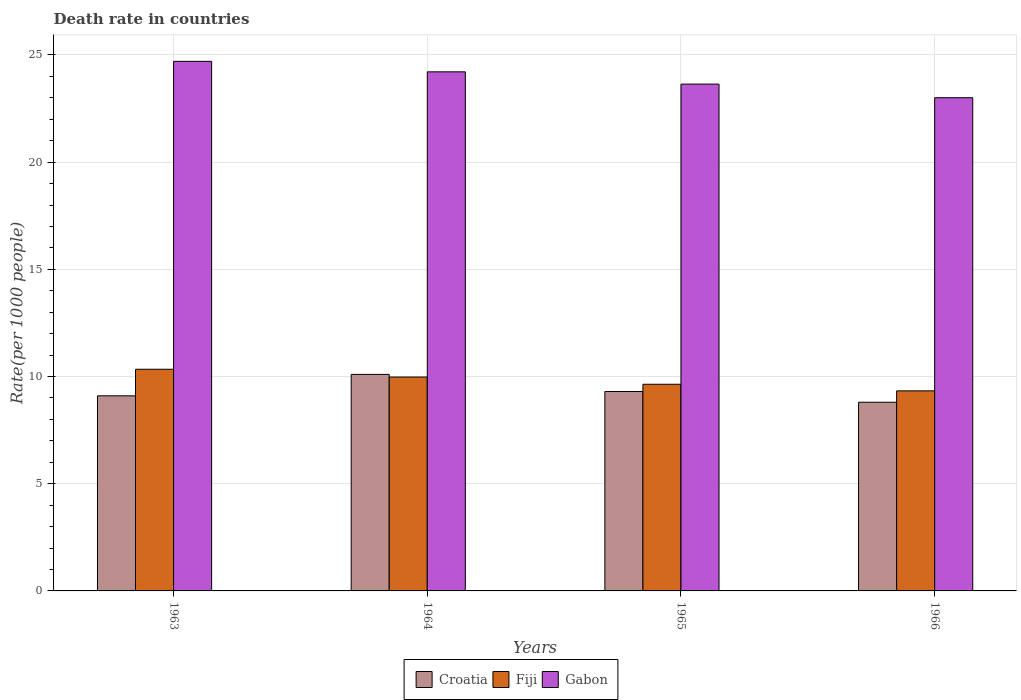How many different coloured bars are there?
Ensure brevity in your answer.  3. How many groups of bars are there?
Ensure brevity in your answer.  4. Are the number of bars per tick equal to the number of legend labels?
Your answer should be very brief. Yes. Are the number of bars on each tick of the X-axis equal?
Provide a short and direct response. Yes. What is the label of the 3rd group of bars from the left?
Keep it short and to the point. 1965. Across all years, what is the maximum death rate in Croatia?
Your response must be concise. 10.1. Across all years, what is the minimum death rate in Gabon?
Your response must be concise. 23. In which year was the death rate in Croatia minimum?
Your answer should be very brief. 1966. What is the total death rate in Fiji in the graph?
Your answer should be compact. 39.28. What is the difference between the death rate in Fiji in 1964 and that in 1966?
Your answer should be very brief. 0.65. What is the difference between the death rate in Fiji in 1966 and the death rate in Croatia in 1963?
Your answer should be compact. 0.23. What is the average death rate in Gabon per year?
Make the answer very short. 23.89. In the year 1964, what is the difference between the death rate in Croatia and death rate in Gabon?
Provide a succinct answer. -14.11. In how many years, is the death rate in Gabon greater than 9?
Your answer should be compact. 4. What is the ratio of the death rate in Fiji in 1964 to that in 1966?
Provide a short and direct response. 1.07. Is the death rate in Fiji in 1964 less than that in 1965?
Provide a succinct answer. No. What is the difference between the highest and the second highest death rate in Croatia?
Provide a short and direct response. 0.8. What is the difference between the highest and the lowest death rate in Fiji?
Your answer should be compact. 1.01. Is the sum of the death rate in Fiji in 1963 and 1964 greater than the maximum death rate in Croatia across all years?
Your response must be concise. Yes. What does the 1st bar from the left in 1966 represents?
Offer a terse response. Croatia. What does the 3rd bar from the right in 1964 represents?
Give a very brief answer. Croatia. Is it the case that in every year, the sum of the death rate in Gabon and death rate in Fiji is greater than the death rate in Croatia?
Provide a short and direct response. Yes. How many bars are there?
Provide a short and direct response. 12. What is the difference between two consecutive major ticks on the Y-axis?
Your response must be concise. 5. Does the graph contain grids?
Provide a short and direct response. Yes. Where does the legend appear in the graph?
Your answer should be compact. Bottom center. What is the title of the graph?
Provide a succinct answer. Death rate in countries. What is the label or title of the Y-axis?
Offer a very short reply. Rate(per 1000 people). What is the Rate(per 1000 people) of Fiji in 1963?
Keep it short and to the point. 10.34. What is the Rate(per 1000 people) in Gabon in 1963?
Make the answer very short. 24.7. What is the Rate(per 1000 people) of Fiji in 1964?
Give a very brief answer. 9.98. What is the Rate(per 1000 people) of Gabon in 1964?
Your response must be concise. 24.21. What is the Rate(per 1000 people) of Croatia in 1965?
Give a very brief answer. 9.3. What is the Rate(per 1000 people) of Fiji in 1965?
Make the answer very short. 9.64. What is the Rate(per 1000 people) of Gabon in 1965?
Make the answer very short. 23.64. What is the Rate(per 1000 people) of Croatia in 1966?
Your answer should be compact. 8.8. What is the Rate(per 1000 people) of Fiji in 1966?
Make the answer very short. 9.33. What is the Rate(per 1000 people) in Gabon in 1966?
Your answer should be compact. 23. Across all years, what is the maximum Rate(per 1000 people) of Fiji?
Keep it short and to the point. 10.34. Across all years, what is the maximum Rate(per 1000 people) in Gabon?
Offer a very short reply. 24.7. Across all years, what is the minimum Rate(per 1000 people) in Croatia?
Offer a terse response. 8.8. Across all years, what is the minimum Rate(per 1000 people) of Fiji?
Your answer should be compact. 9.33. Across all years, what is the minimum Rate(per 1000 people) in Gabon?
Keep it short and to the point. 23. What is the total Rate(per 1000 people) in Croatia in the graph?
Provide a succinct answer. 37.3. What is the total Rate(per 1000 people) of Fiji in the graph?
Provide a short and direct response. 39.28. What is the total Rate(per 1000 people) in Gabon in the graph?
Make the answer very short. 95.55. What is the difference between the Rate(per 1000 people) of Croatia in 1963 and that in 1964?
Your response must be concise. -1. What is the difference between the Rate(per 1000 people) in Fiji in 1963 and that in 1964?
Give a very brief answer. 0.36. What is the difference between the Rate(per 1000 people) in Gabon in 1963 and that in 1964?
Offer a terse response. 0.49. What is the difference between the Rate(per 1000 people) of Croatia in 1963 and that in 1965?
Keep it short and to the point. -0.2. What is the difference between the Rate(per 1000 people) in Fiji in 1963 and that in 1965?
Provide a succinct answer. 0.7. What is the difference between the Rate(per 1000 people) of Gabon in 1963 and that in 1965?
Offer a terse response. 1.06. What is the difference between the Rate(per 1000 people) of Fiji in 1963 and that in 1966?
Offer a terse response. 1.01. What is the difference between the Rate(per 1000 people) of Gabon in 1963 and that in 1966?
Your response must be concise. 1.7. What is the difference between the Rate(per 1000 people) of Croatia in 1964 and that in 1965?
Make the answer very short. 0.8. What is the difference between the Rate(per 1000 people) in Fiji in 1964 and that in 1965?
Provide a succinct answer. 0.34. What is the difference between the Rate(per 1000 people) of Gabon in 1964 and that in 1965?
Offer a terse response. 0.57. What is the difference between the Rate(per 1000 people) of Croatia in 1964 and that in 1966?
Offer a terse response. 1.3. What is the difference between the Rate(per 1000 people) in Fiji in 1964 and that in 1966?
Your answer should be compact. 0.65. What is the difference between the Rate(per 1000 people) in Gabon in 1964 and that in 1966?
Offer a very short reply. 1.21. What is the difference between the Rate(per 1000 people) in Fiji in 1965 and that in 1966?
Offer a terse response. 0.31. What is the difference between the Rate(per 1000 people) of Gabon in 1965 and that in 1966?
Ensure brevity in your answer.  0.64. What is the difference between the Rate(per 1000 people) in Croatia in 1963 and the Rate(per 1000 people) in Fiji in 1964?
Keep it short and to the point. -0.88. What is the difference between the Rate(per 1000 people) of Croatia in 1963 and the Rate(per 1000 people) of Gabon in 1964?
Make the answer very short. -15.11. What is the difference between the Rate(per 1000 people) of Fiji in 1963 and the Rate(per 1000 people) of Gabon in 1964?
Provide a succinct answer. -13.87. What is the difference between the Rate(per 1000 people) of Croatia in 1963 and the Rate(per 1000 people) of Fiji in 1965?
Your response must be concise. -0.54. What is the difference between the Rate(per 1000 people) of Croatia in 1963 and the Rate(per 1000 people) of Gabon in 1965?
Offer a terse response. -14.54. What is the difference between the Rate(per 1000 people) in Fiji in 1963 and the Rate(per 1000 people) in Gabon in 1965?
Make the answer very short. -13.3. What is the difference between the Rate(per 1000 people) in Croatia in 1963 and the Rate(per 1000 people) in Fiji in 1966?
Ensure brevity in your answer.  -0.23. What is the difference between the Rate(per 1000 people) of Croatia in 1963 and the Rate(per 1000 people) of Gabon in 1966?
Provide a succinct answer. -13.9. What is the difference between the Rate(per 1000 people) of Fiji in 1963 and the Rate(per 1000 people) of Gabon in 1966?
Your answer should be compact. -12.66. What is the difference between the Rate(per 1000 people) in Croatia in 1964 and the Rate(per 1000 people) in Fiji in 1965?
Offer a terse response. 0.46. What is the difference between the Rate(per 1000 people) in Croatia in 1964 and the Rate(per 1000 people) in Gabon in 1965?
Make the answer very short. -13.54. What is the difference between the Rate(per 1000 people) in Fiji in 1964 and the Rate(per 1000 people) in Gabon in 1965?
Provide a short and direct response. -13.66. What is the difference between the Rate(per 1000 people) of Croatia in 1964 and the Rate(per 1000 people) of Fiji in 1966?
Your answer should be compact. 0.77. What is the difference between the Rate(per 1000 people) of Croatia in 1964 and the Rate(per 1000 people) of Gabon in 1966?
Offer a terse response. -12.9. What is the difference between the Rate(per 1000 people) in Fiji in 1964 and the Rate(per 1000 people) in Gabon in 1966?
Your answer should be compact. -13.03. What is the difference between the Rate(per 1000 people) of Croatia in 1965 and the Rate(per 1000 people) of Fiji in 1966?
Your answer should be compact. -0.03. What is the difference between the Rate(per 1000 people) of Croatia in 1965 and the Rate(per 1000 people) of Gabon in 1966?
Provide a short and direct response. -13.7. What is the difference between the Rate(per 1000 people) of Fiji in 1965 and the Rate(per 1000 people) of Gabon in 1966?
Your answer should be very brief. -13.37. What is the average Rate(per 1000 people) in Croatia per year?
Offer a very short reply. 9.32. What is the average Rate(per 1000 people) in Fiji per year?
Keep it short and to the point. 9.82. What is the average Rate(per 1000 people) of Gabon per year?
Your answer should be compact. 23.89. In the year 1963, what is the difference between the Rate(per 1000 people) in Croatia and Rate(per 1000 people) in Fiji?
Keep it short and to the point. -1.24. In the year 1963, what is the difference between the Rate(per 1000 people) of Croatia and Rate(per 1000 people) of Gabon?
Your response must be concise. -15.6. In the year 1963, what is the difference between the Rate(per 1000 people) of Fiji and Rate(per 1000 people) of Gabon?
Provide a succinct answer. -14.36. In the year 1964, what is the difference between the Rate(per 1000 people) in Croatia and Rate(per 1000 people) in Fiji?
Give a very brief answer. 0.12. In the year 1964, what is the difference between the Rate(per 1000 people) of Croatia and Rate(per 1000 people) of Gabon?
Make the answer very short. -14.11. In the year 1964, what is the difference between the Rate(per 1000 people) in Fiji and Rate(per 1000 people) in Gabon?
Offer a terse response. -14.23. In the year 1965, what is the difference between the Rate(per 1000 people) of Croatia and Rate(per 1000 people) of Fiji?
Ensure brevity in your answer.  -0.34. In the year 1965, what is the difference between the Rate(per 1000 people) in Croatia and Rate(per 1000 people) in Gabon?
Provide a short and direct response. -14.34. In the year 1965, what is the difference between the Rate(per 1000 people) of Fiji and Rate(per 1000 people) of Gabon?
Keep it short and to the point. -14. In the year 1966, what is the difference between the Rate(per 1000 people) of Croatia and Rate(per 1000 people) of Fiji?
Make the answer very short. -0.53. In the year 1966, what is the difference between the Rate(per 1000 people) in Croatia and Rate(per 1000 people) in Gabon?
Ensure brevity in your answer.  -14.2. In the year 1966, what is the difference between the Rate(per 1000 people) in Fiji and Rate(per 1000 people) in Gabon?
Provide a short and direct response. -13.67. What is the ratio of the Rate(per 1000 people) in Croatia in 1963 to that in 1964?
Make the answer very short. 0.9. What is the ratio of the Rate(per 1000 people) in Fiji in 1963 to that in 1964?
Offer a very short reply. 1.04. What is the ratio of the Rate(per 1000 people) in Gabon in 1963 to that in 1964?
Ensure brevity in your answer.  1.02. What is the ratio of the Rate(per 1000 people) in Croatia in 1963 to that in 1965?
Provide a short and direct response. 0.98. What is the ratio of the Rate(per 1000 people) in Fiji in 1963 to that in 1965?
Offer a terse response. 1.07. What is the ratio of the Rate(per 1000 people) in Gabon in 1963 to that in 1965?
Offer a very short reply. 1.04. What is the ratio of the Rate(per 1000 people) in Croatia in 1963 to that in 1966?
Keep it short and to the point. 1.03. What is the ratio of the Rate(per 1000 people) of Fiji in 1963 to that in 1966?
Your answer should be compact. 1.11. What is the ratio of the Rate(per 1000 people) in Gabon in 1963 to that in 1966?
Give a very brief answer. 1.07. What is the ratio of the Rate(per 1000 people) of Croatia in 1964 to that in 1965?
Your response must be concise. 1.09. What is the ratio of the Rate(per 1000 people) in Fiji in 1964 to that in 1965?
Make the answer very short. 1.03. What is the ratio of the Rate(per 1000 people) of Gabon in 1964 to that in 1965?
Ensure brevity in your answer.  1.02. What is the ratio of the Rate(per 1000 people) of Croatia in 1964 to that in 1966?
Your answer should be compact. 1.15. What is the ratio of the Rate(per 1000 people) of Fiji in 1964 to that in 1966?
Give a very brief answer. 1.07. What is the ratio of the Rate(per 1000 people) in Gabon in 1964 to that in 1966?
Offer a very short reply. 1.05. What is the ratio of the Rate(per 1000 people) of Croatia in 1965 to that in 1966?
Provide a short and direct response. 1.06. What is the ratio of the Rate(per 1000 people) in Fiji in 1965 to that in 1966?
Your answer should be compact. 1.03. What is the ratio of the Rate(per 1000 people) of Gabon in 1965 to that in 1966?
Ensure brevity in your answer.  1.03. What is the difference between the highest and the second highest Rate(per 1000 people) in Fiji?
Make the answer very short. 0.36. What is the difference between the highest and the second highest Rate(per 1000 people) in Gabon?
Your answer should be compact. 0.49. What is the difference between the highest and the lowest Rate(per 1000 people) of Gabon?
Provide a succinct answer. 1.7. 